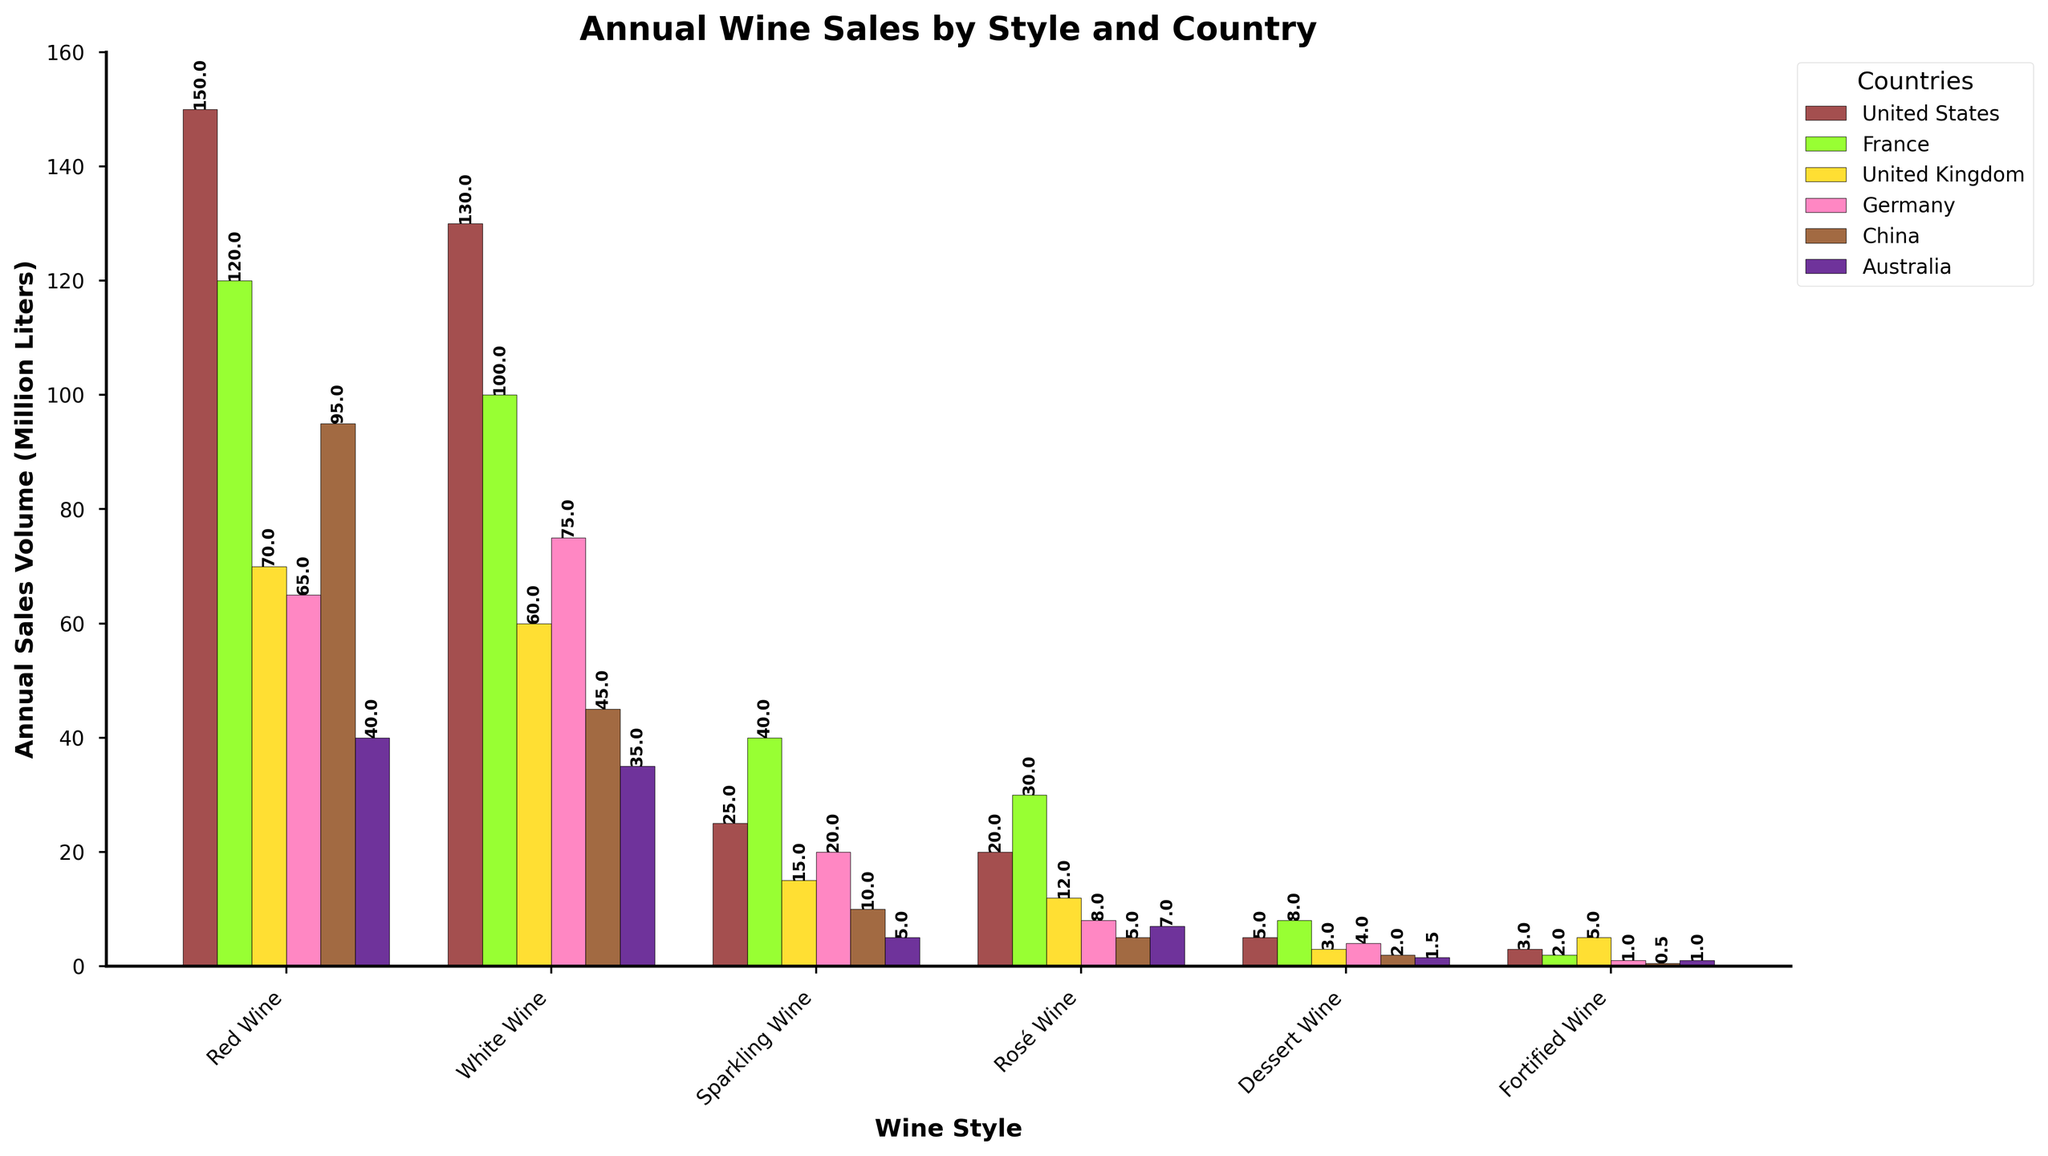Which country has the highest annual sales volume of Red Wine? By looking at the height of the bars in the Red Wine category, the United States has the highest bar compared to other countries
Answer: United States Which wine style has the lowest annual sales volume in China? By looking at the height of the bars in China, Fortified Wine has the lowest bar in the China category
Answer: Fortified Wine What is the total annual sales volume of Sparkling Wine across all countries? Sum the height of all bars in Sparkling Wine: 25 + 40 + 15 + 20 + 10 + 5 = 115 (million liters)
Answer: 115 million liters Which country sells more White Wine than Red Wine? By comparing the height of the Red and White Wine bars in each country, Germany and Australia sell more White Wine than Red Wine
Answer: Germany, Australia What is the difference in annual sales volumes of Rosé Wine between France and Germany? Subtract the height of Germany's Rosé Wine bar from France's Rosé Wine bar: 30 - 8 = 22 (million liters)
Answer: 22 million liters If you combine the sales of Dessert Wine and Fortified Wine in the United Kingdom, what is the total volume? Sum the height of the Dessert Wine bar (3) and Fortified Wine bar (5) in the United Kingdom: 3 + 5 = 8 (million liters)
Answer: 8 million liters What is the average annual sales volume of White Wine across the listed countries? Sum the heights of all White Wine bars: 130 + 100 + 60 + 75 + 45 + 35 = 445. Then divide by the number of countries: 445 / 6 ≈ 74.2 (million liters)
Answer: 74.2 million liters Which country has the second-highest annual sales volume for Sparkling Wine? By comparing the height of the Sparkling Wine bars, France has the highest, and Germany has the second-highest
Answer: Germany 